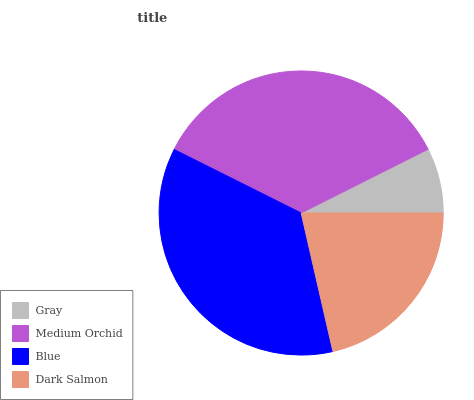Is Gray the minimum?
Answer yes or no. Yes. Is Blue the maximum?
Answer yes or no. Yes. Is Medium Orchid the minimum?
Answer yes or no. No. Is Medium Orchid the maximum?
Answer yes or no. No. Is Medium Orchid greater than Gray?
Answer yes or no. Yes. Is Gray less than Medium Orchid?
Answer yes or no. Yes. Is Gray greater than Medium Orchid?
Answer yes or no. No. Is Medium Orchid less than Gray?
Answer yes or no. No. Is Medium Orchid the high median?
Answer yes or no. Yes. Is Dark Salmon the low median?
Answer yes or no. Yes. Is Dark Salmon the high median?
Answer yes or no. No. Is Medium Orchid the low median?
Answer yes or no. No. 